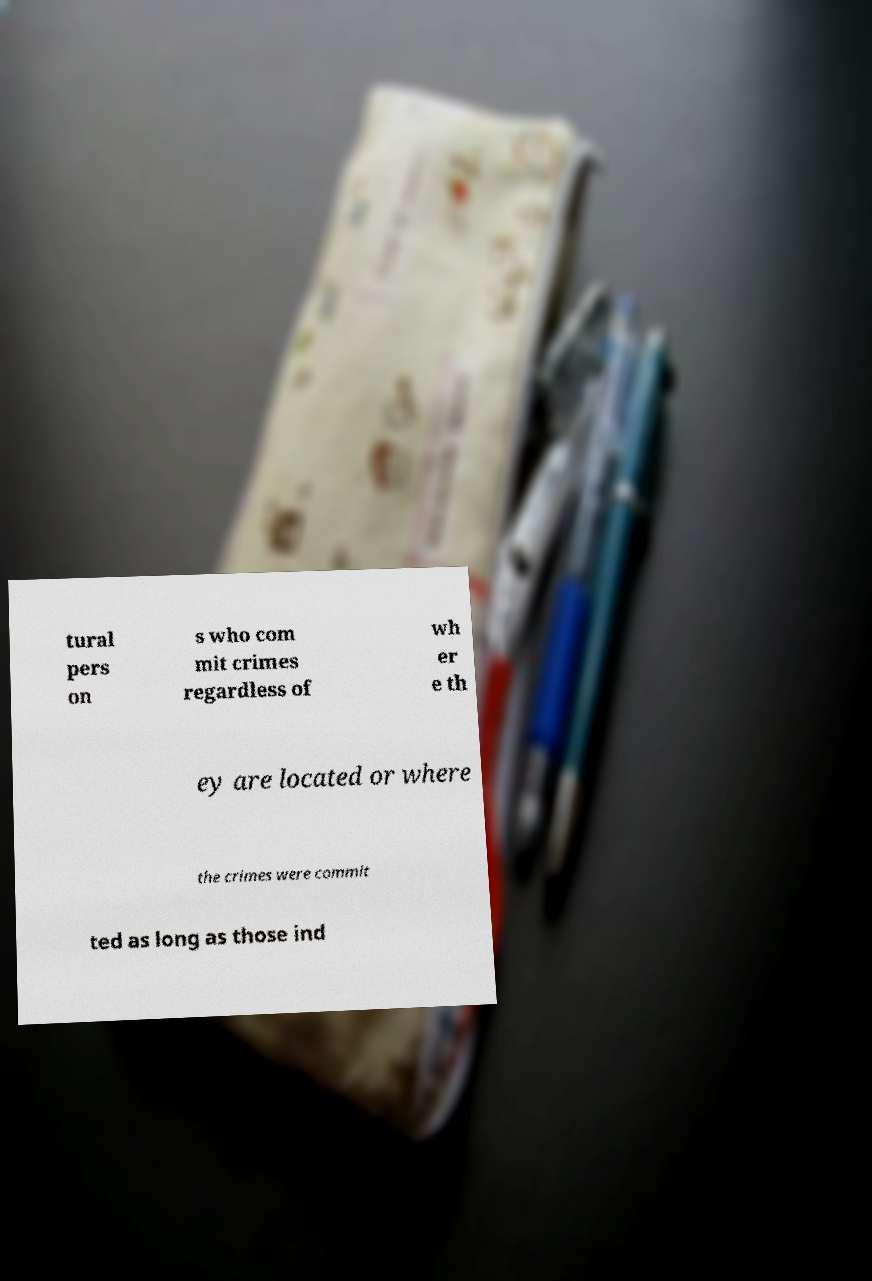Can you read and provide the text displayed in the image?This photo seems to have some interesting text. Can you extract and type it out for me? tural pers on s who com mit crimes regardless of wh er e th ey are located or where the crimes were commit ted as long as those ind 